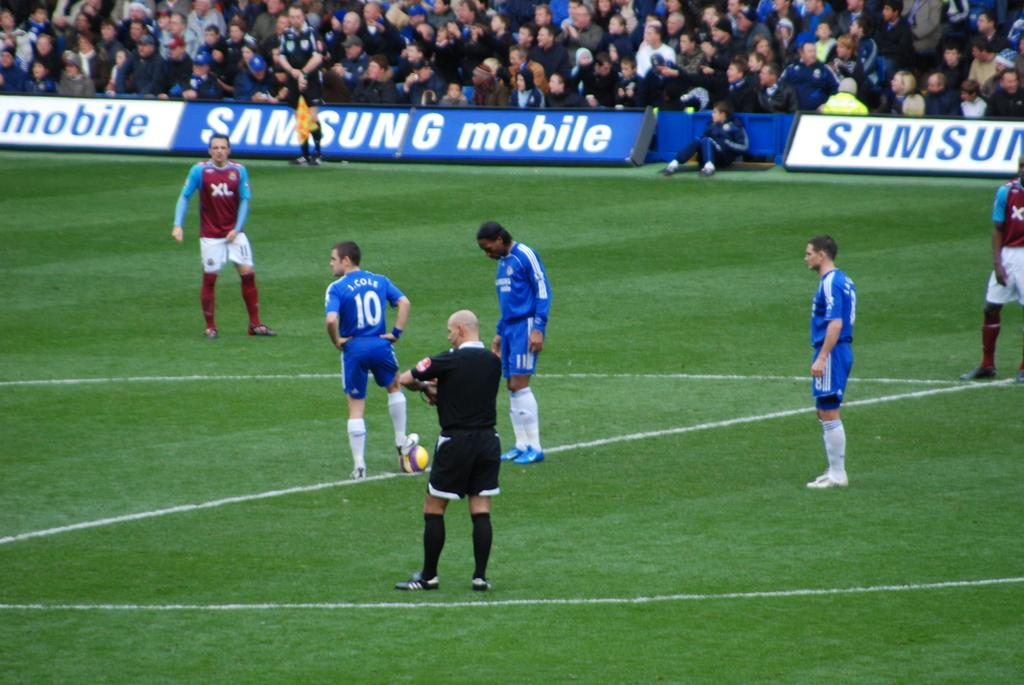<image>
Summarize the visual content of the image. J. Cole #10 stands with his teammates and opponents on the Samsung Mobile sponsored soccer field. 